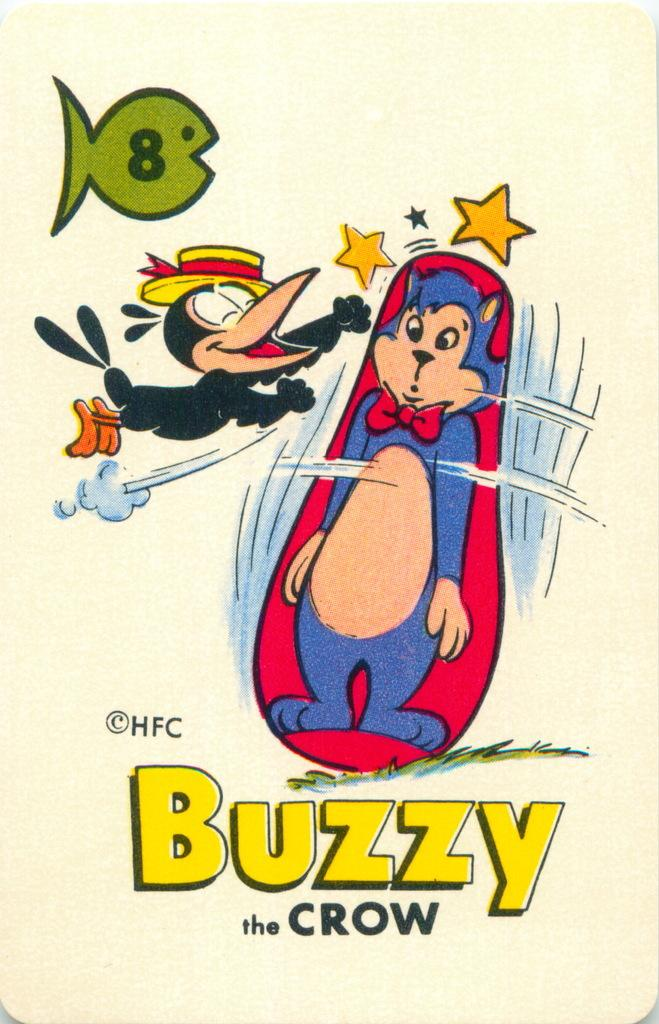<image>
Relay a brief, clear account of the picture shown. Drawing of a bird and a cat with the words "Buzzy the Crow" on the bottom. 